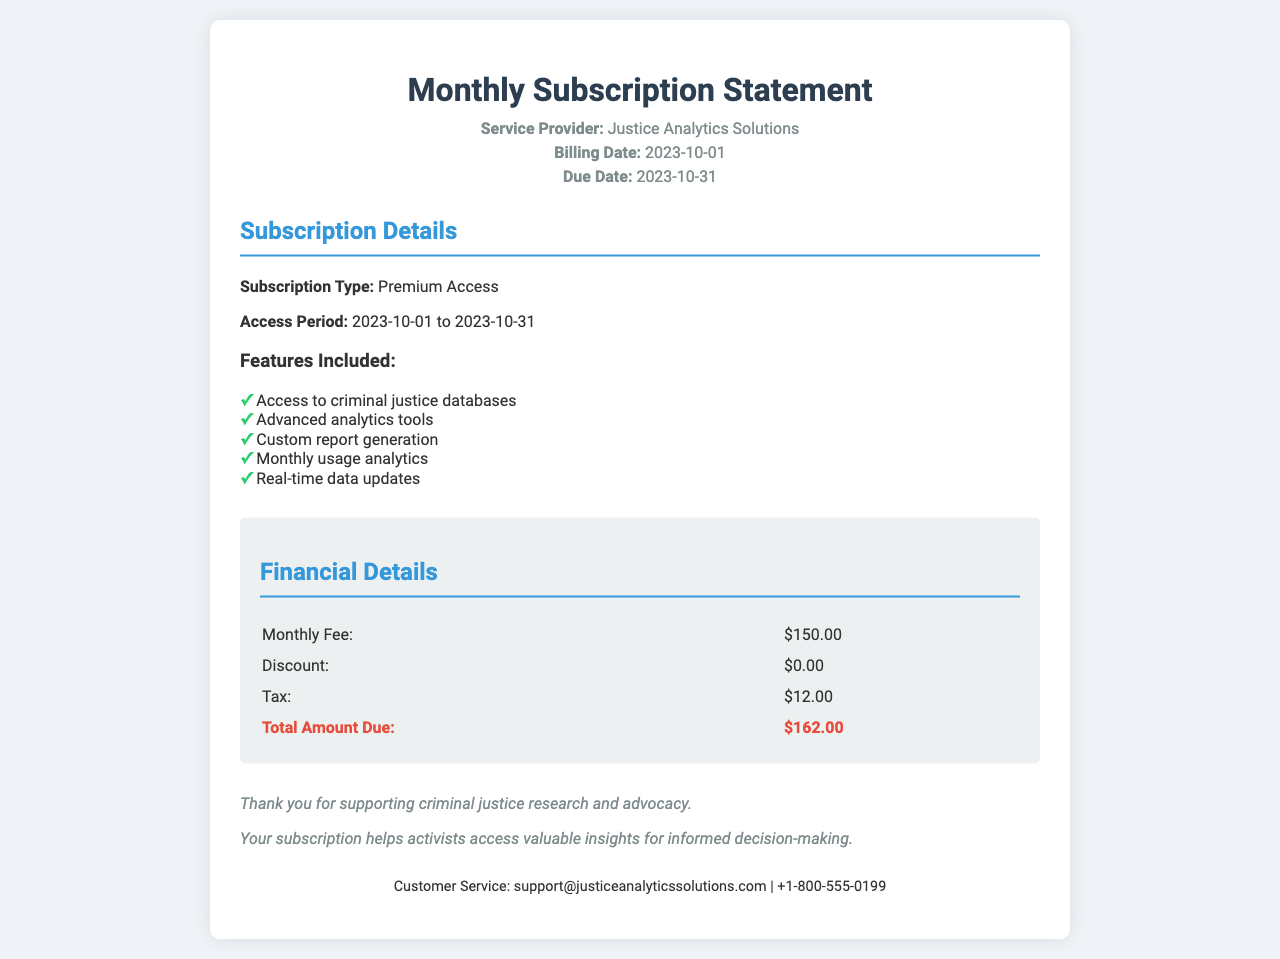What is the name of the service provider? The service provider is mentioned in the document as "Justice Analytics Solutions."
Answer: Justice Analytics Solutions What is the billing date? The billing date is clearly stated in the document.
Answer: 2023-10-01 What is the total amount due? The total amount due is calculated at the end of the financial details section.
Answer: $162.00 How long is the access period? The access period is given in the subscription details section.
Answer: 2023-10-01 to 2023-10-31 What is the monthly fee for the subscription? The monthly fee is specified in the financial details section.
Answer: $150.00 How much tax is included? The tax amount is listed under financial details.
Answer: $12.00 What features are included in the subscription? The features available are listed in bullet points under subscription details.
Answer: Access to criminal justice databases, Advanced analytics tools, Custom report generation, Monthly usage analytics, Real-time data updates What type of subscription is featured? The type of subscription is specified in the subscription details section.
Answer: Premium Access What is included in the notes section? The notes section expresses gratitude and highlights the importance of the subscription for research and advocacy.
Answer: Thank you for supporting criminal justice research and advocacy. Your subscription helps activists access valuable insights for informed decision-making 